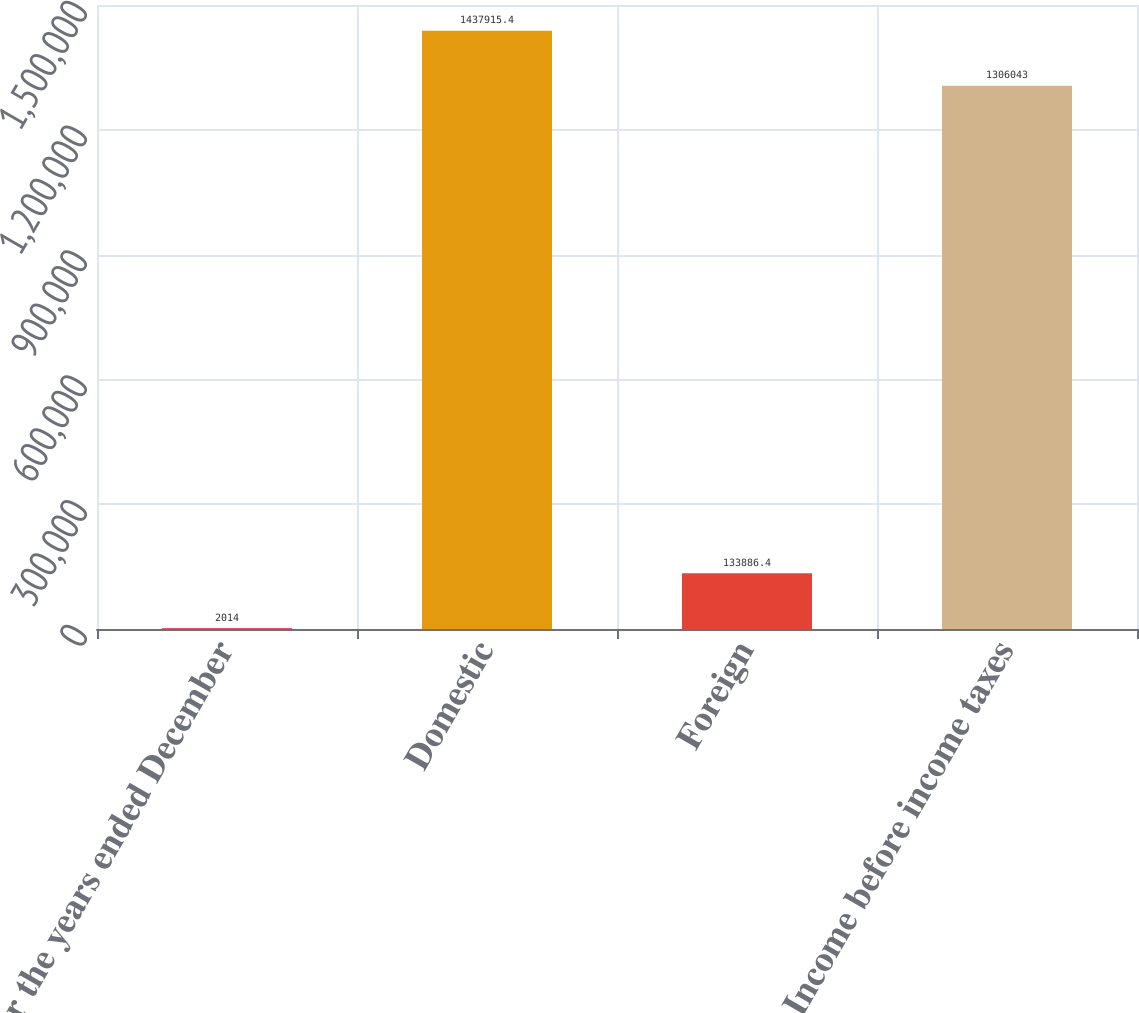<chart> <loc_0><loc_0><loc_500><loc_500><bar_chart><fcel>For the years ended December<fcel>Domestic<fcel>Foreign<fcel>Income before income taxes<nl><fcel>2014<fcel>1.43792e+06<fcel>133886<fcel>1.30604e+06<nl></chart> 